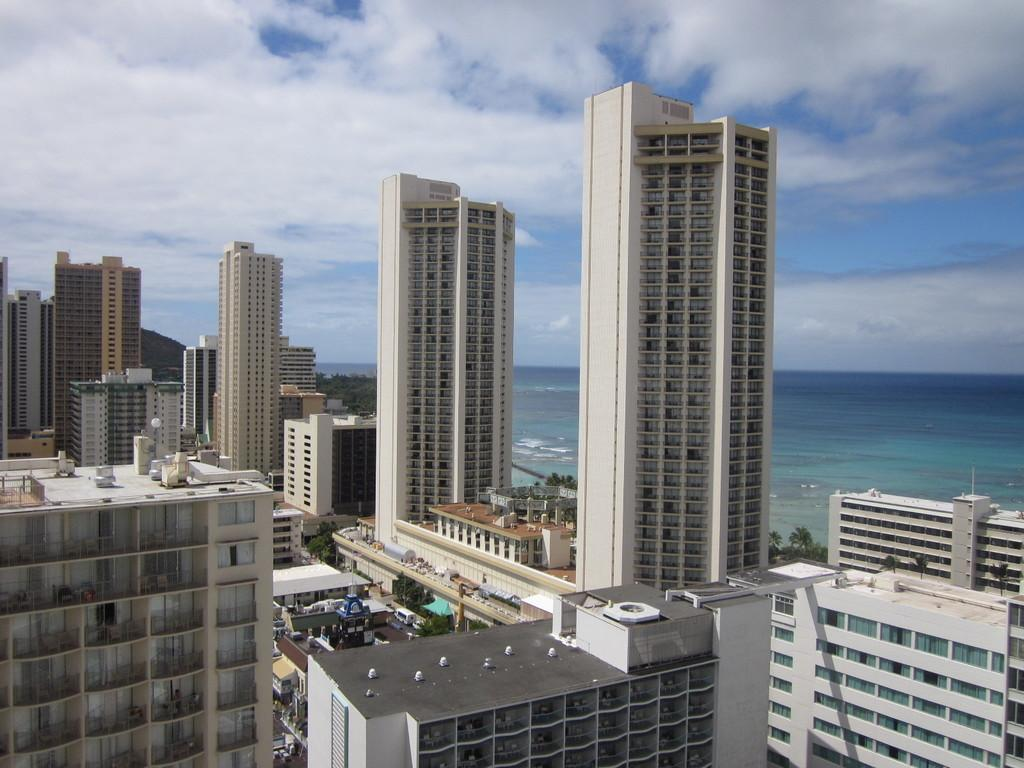What type of structures are present in the image? There are buildings and skyscrapers in the image. What can be seen at the bottom of the image? There are trees at the bottom of the image. What natural feature is on the right side of the image? There is a beach on the right side of the image. What is visible at the top of the image? The sky is visible at the top of the image. What type of zinc is present on the beach in the image? There is no zinc present on the beach in the image. How many eggs can be seen in the image? There are no eggs visible in the image. 